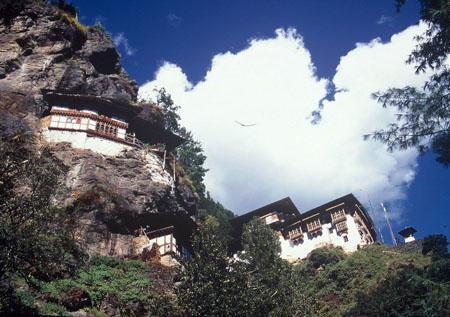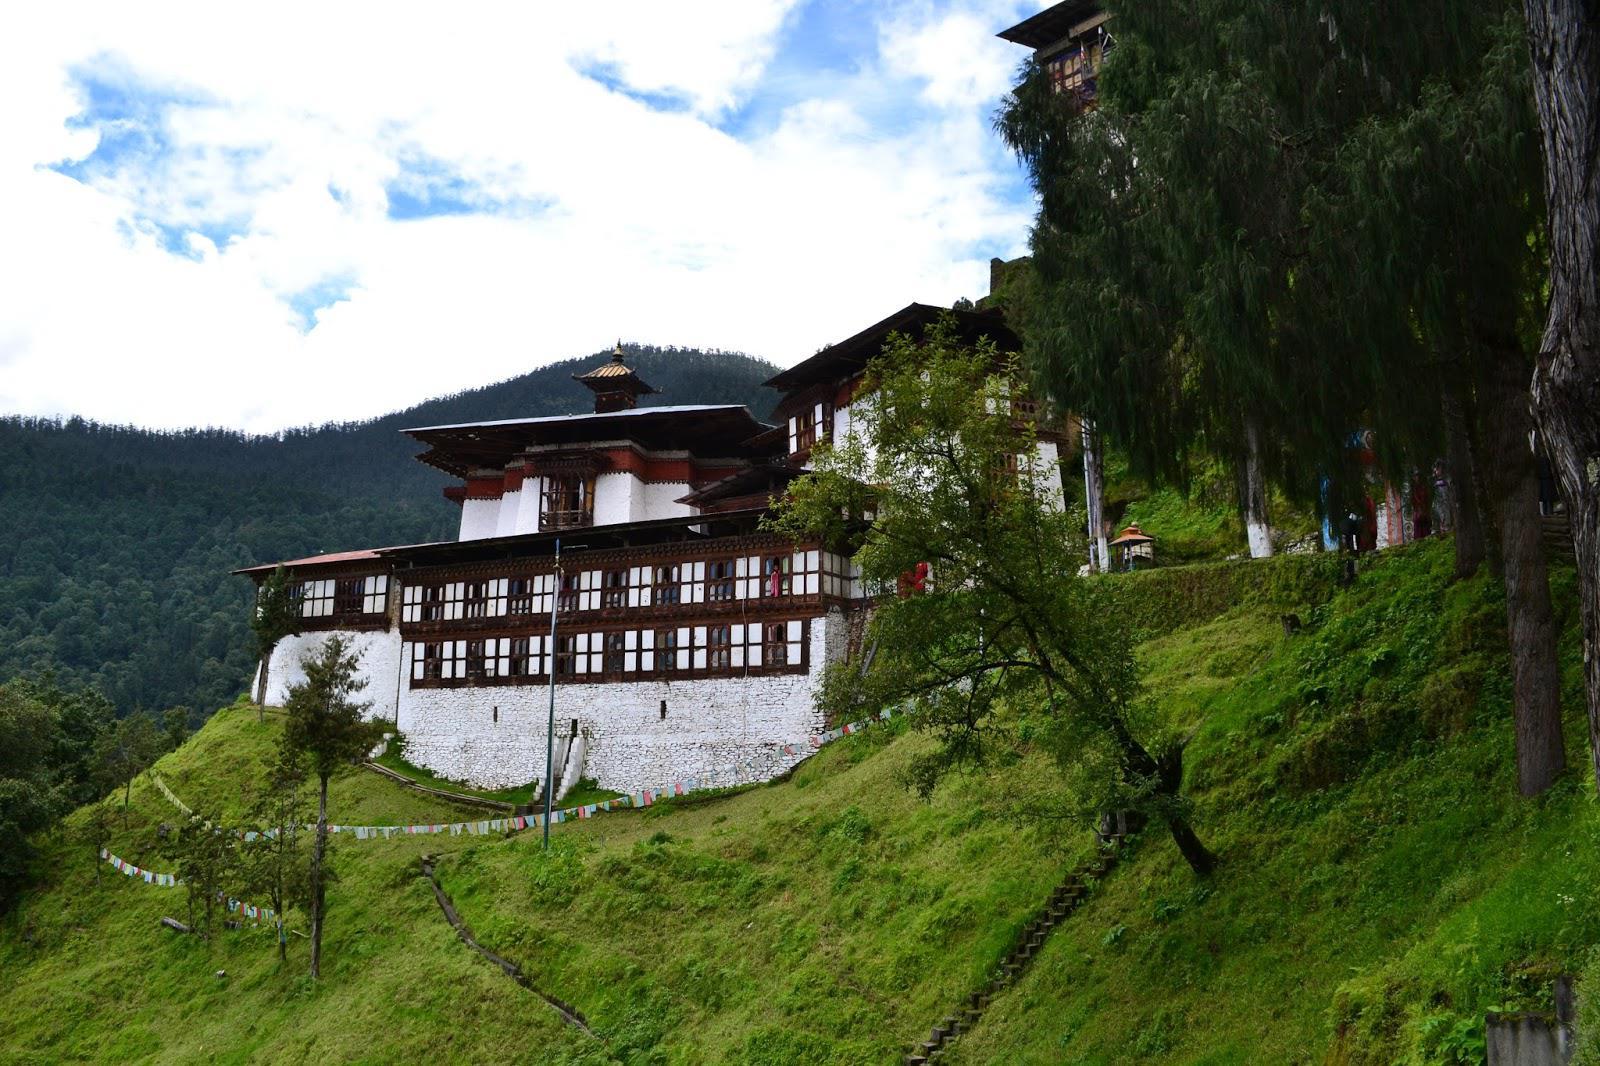The first image is the image on the left, the second image is the image on the right. Given the left and right images, does the statement "In at least one image there are people outside of a monastery." hold true? Answer yes or no. No. The first image is the image on the left, the second image is the image on the right. For the images shown, is this caption "An image shows multiple people in front of a hillside building." true? Answer yes or no. No. The first image is the image on the left, the second image is the image on the right. Considering the images on both sides, is "In one of the images there is more than one person." valid? Answer yes or no. No. 